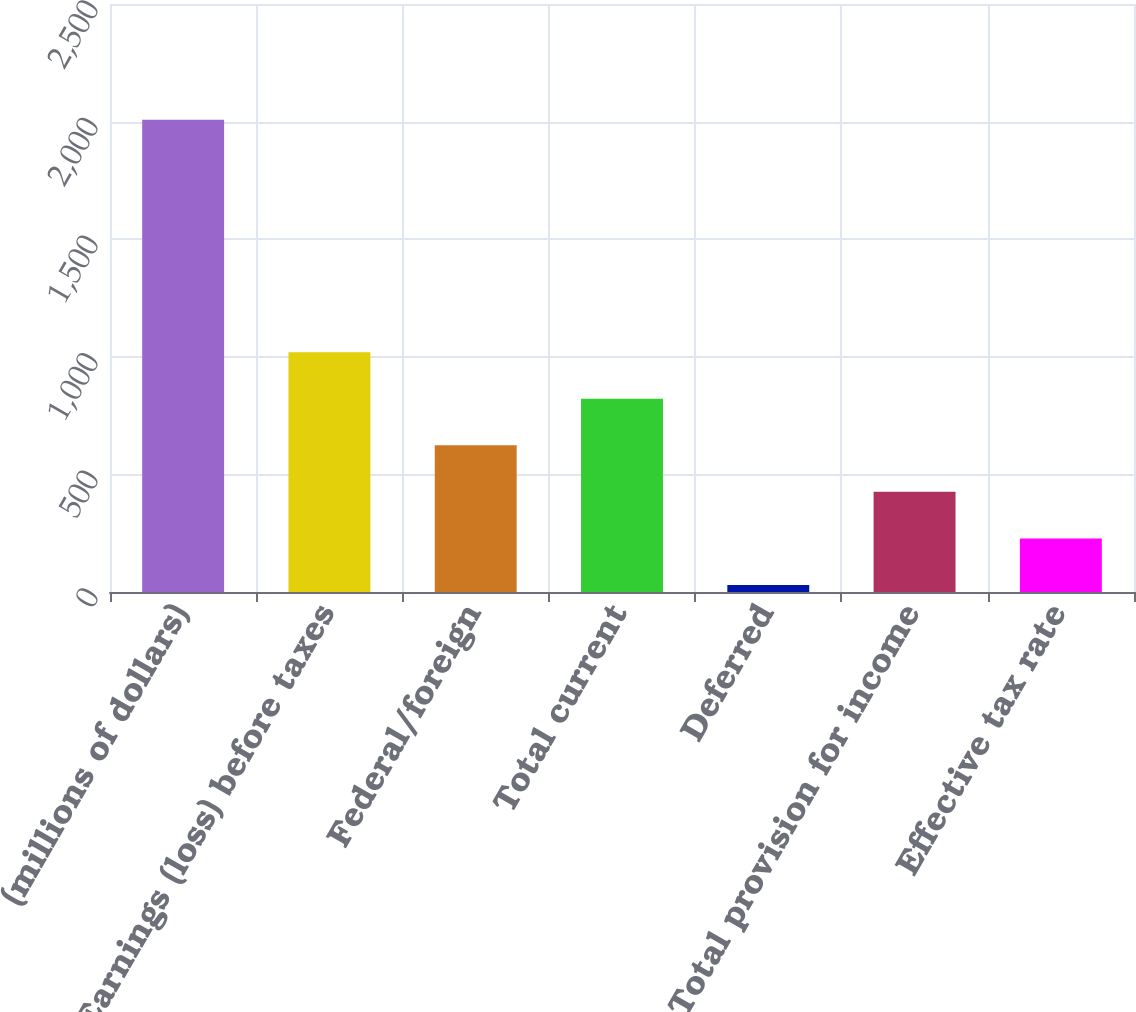<chart> <loc_0><loc_0><loc_500><loc_500><bar_chart><fcel>(millions of dollars)<fcel>Earnings (loss) before taxes<fcel>Federal/foreign<fcel>Total current<fcel>Deferred<fcel>Total provision for income<fcel>Effective tax rate<nl><fcel>2008<fcel>1019.1<fcel>623.54<fcel>821.32<fcel>30.2<fcel>425.76<fcel>227.98<nl></chart> 